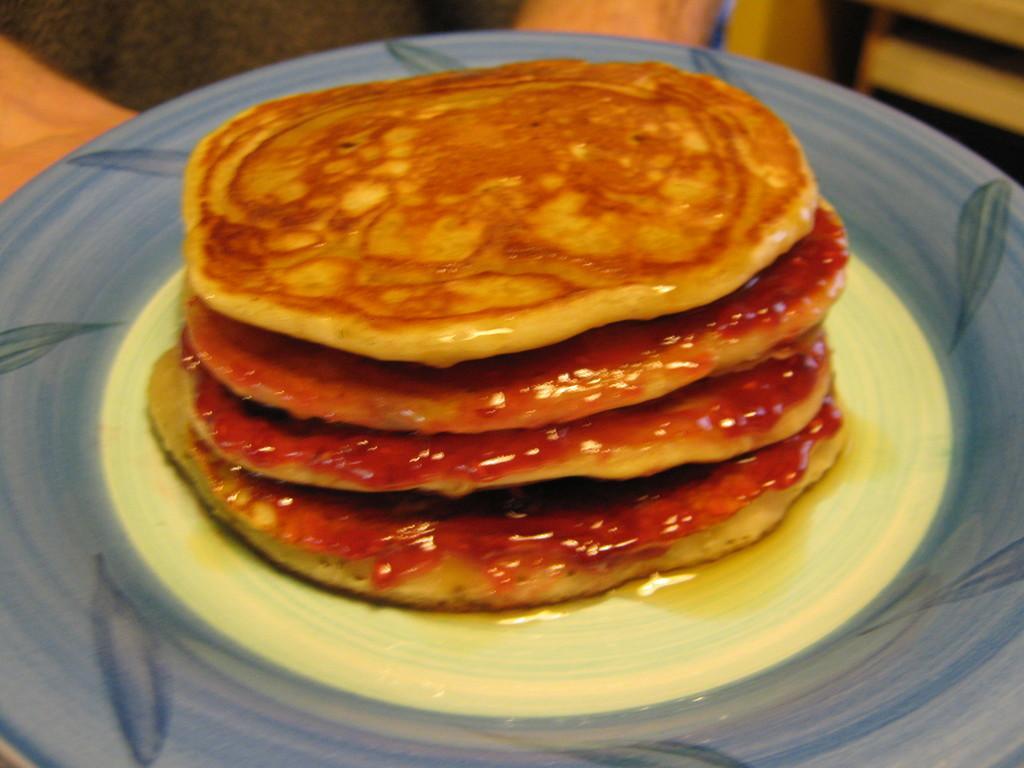Describe this image in one or two sentences. In this image in the middle, there is a plate on that there are pancakes. 